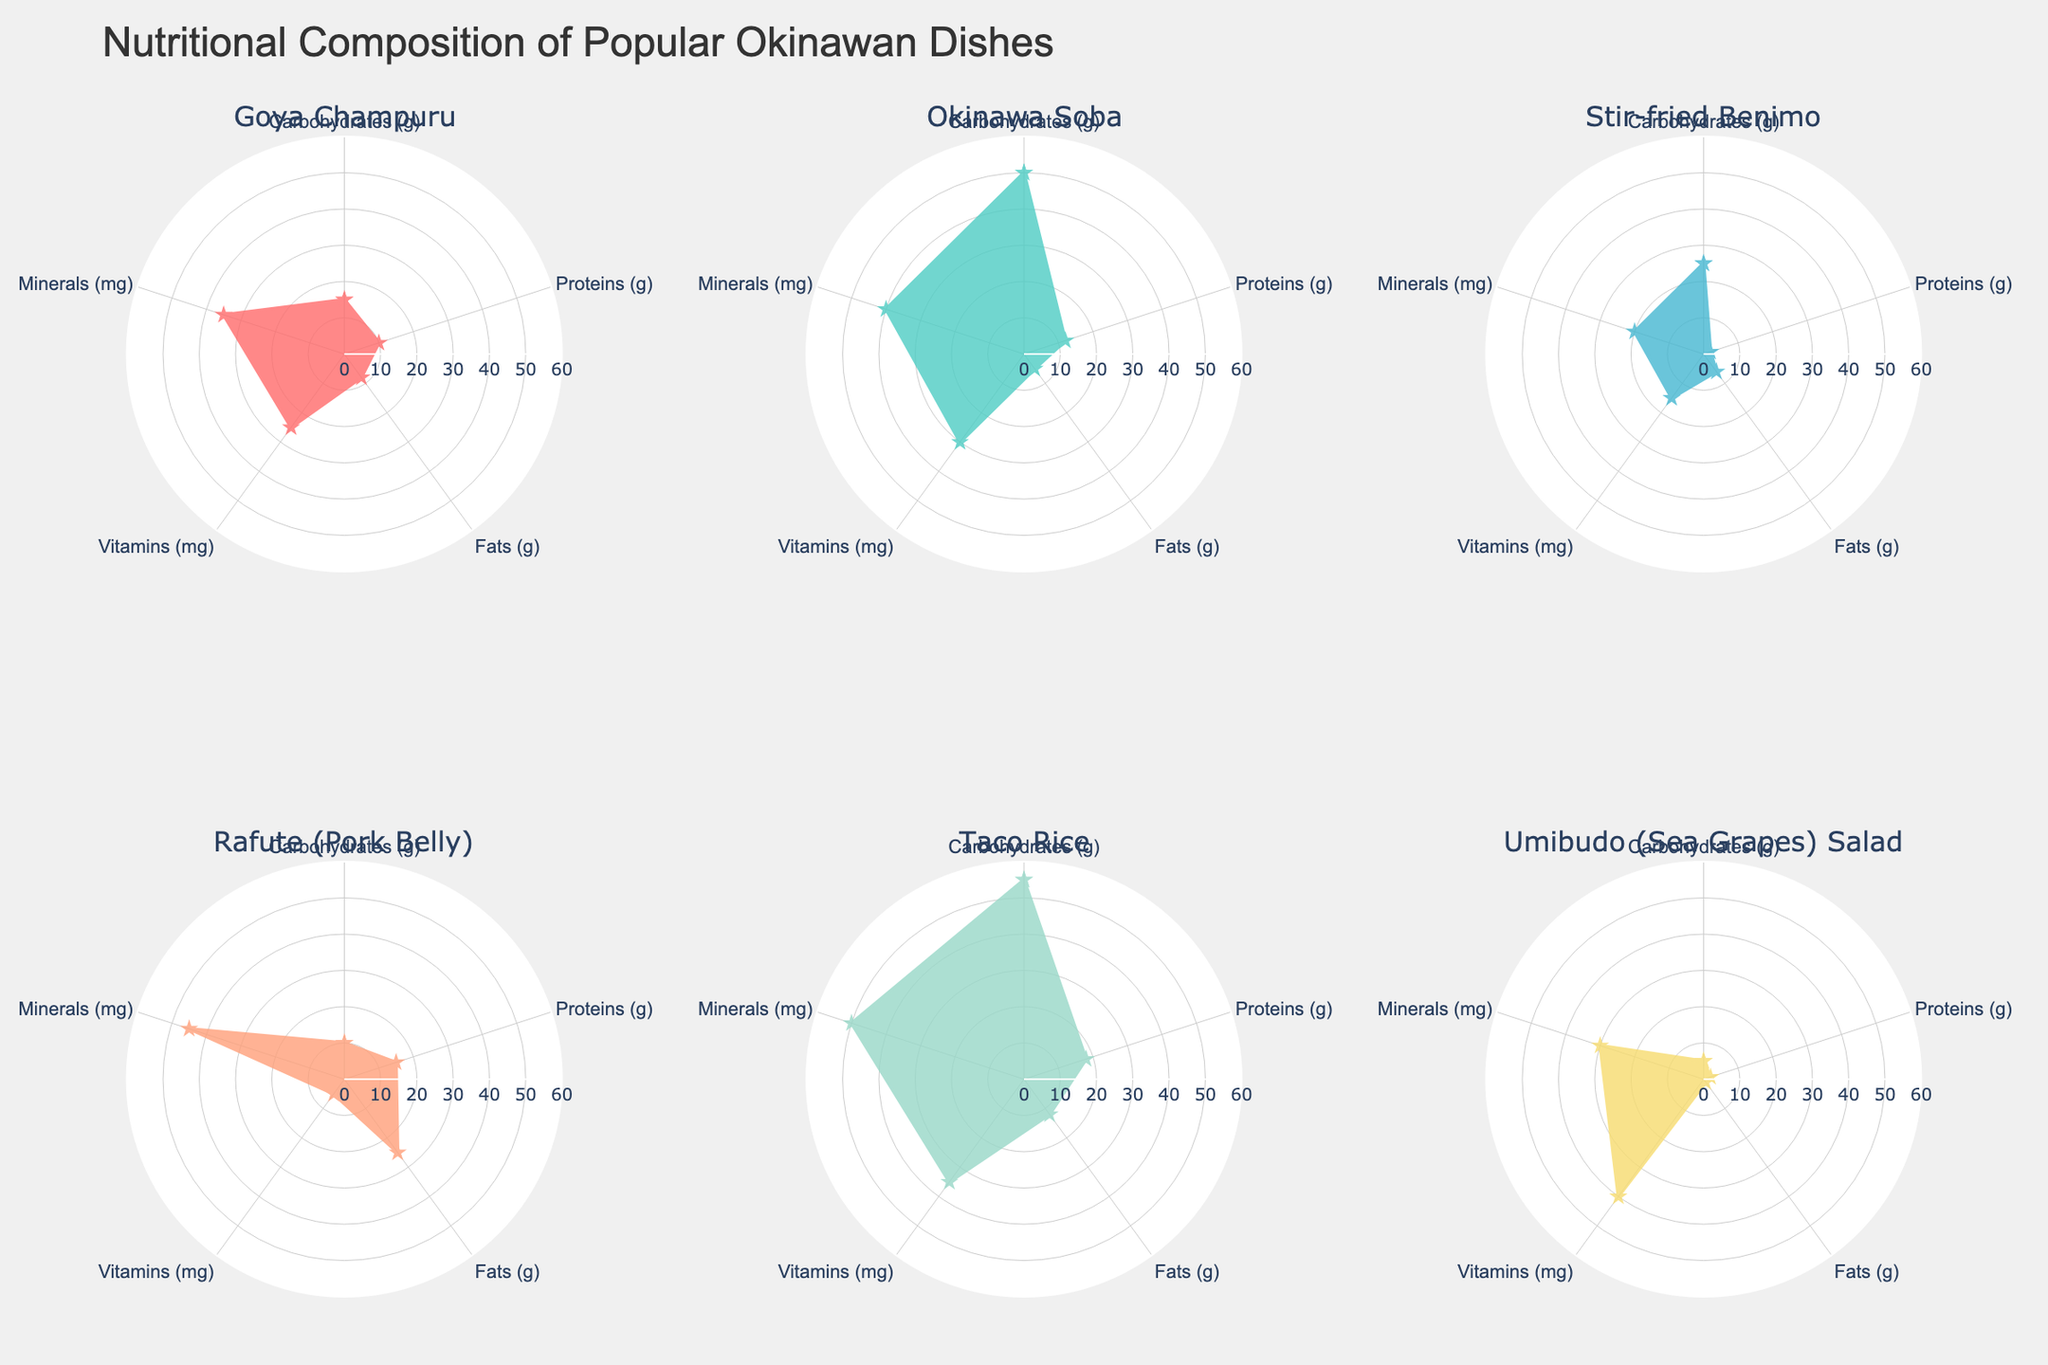What is the title of the figure? The title of the figure is located at the top center. It states the main subject of the plot, which is the nutritional composition of certain dishes.
Answer: Nutritional Composition of Popular Okinawan Dishes Which dish has the highest carbohydrate content? By looking at the radial lines under “Carbohydrates (g)”, the dish with the longest line indicates the highest carbohydrate content.
Answer: Taco Rice What are the colors used for the different dishes? The colors are easily distinguishable and are directly linked with each dish name in the subplots. They range from red to light brown and shades in between.
Answer: Red, Cyan, Light Blue, Light Salmon, Light Green, Yellow Which dish has the lowest fat content? Check the radial line for “Fats (g)”; the dish with the shortest line in that direction has the lowest fat content.
Answer: Umibudo (Sea Grapes) Salad Which dish is the highest in minerals? Look at the radial lines under “Minerals (mg)” in all subplots; the one stretching farthest has the most minerals.
Answer: Taco Rice How does Rafute's protein content compare with Goya Champuru? Locate the radial lines for “Proteins (g)” in the subplots of Rafute and Goya Champuru, then compare their lengths.
Answer: Rafute has more proteins than Goya Champuru What is the combined total of vitamins in Goya Champuru and Umibudo Salad? Check the radial length for “Vitamins (mg)” for both dishes, then add them together. Goya Champuru has 25 mg and Umibudo Salad has 40 mg. 25+40=65
Answer: 65 mg How does the carbohydrate content in Okinawa Soba compare to Taco Rice? Looking at the radial length for “Carbohydrates (g)” for both dishes, compare their lengths. Taco Rice has 55g and Okinawa Soba has 50g.
Answer: Taco Rice has slightly more carbohydrates than Okinawa Soba Which dish has the most balanced nutritional composition in terms of all categories being nearly equal? Look for a dish whose radii are all roughly the same length, indicating a balanced composition.
Answer: Okinawa Soba What is the range of the radial axis? The radial axis has lines emanating from the center outwards; its range can be seen by the grid lines and values.
Answer: 0 to 60 